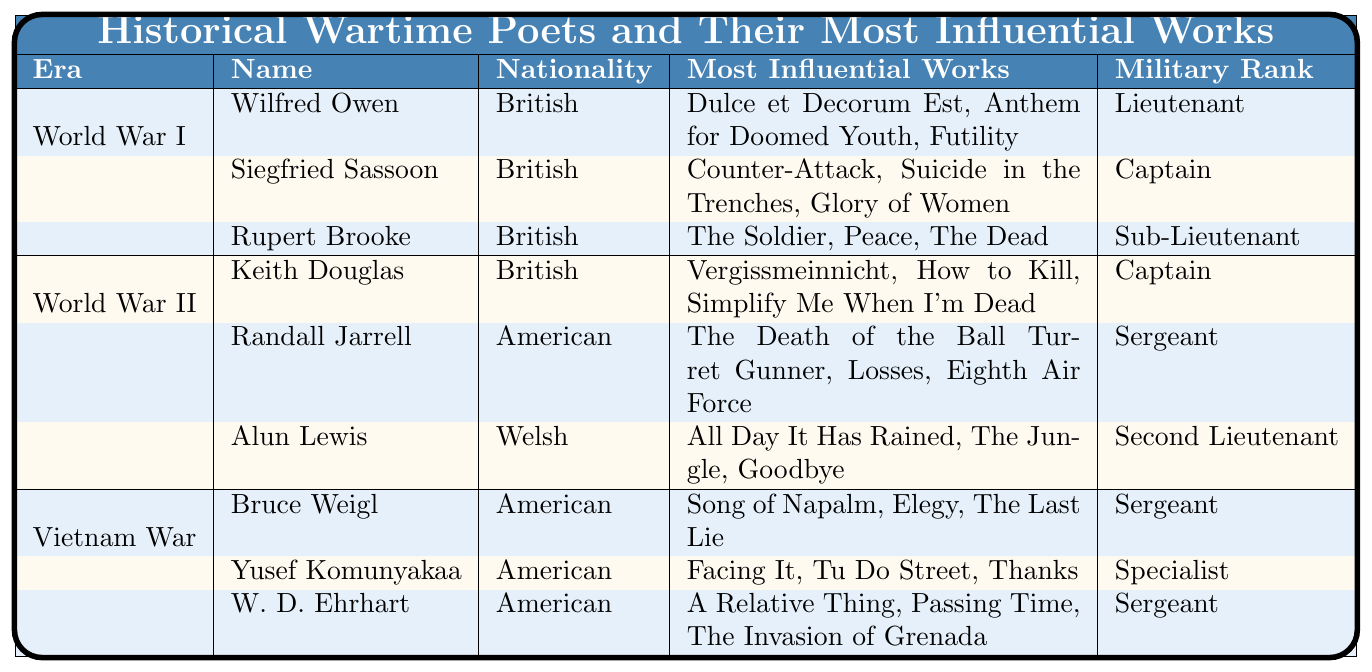What is the nationality of Wilfred Owen? The table lists Wilfred Owen under the "World War I" era and states his nationality is "British."
Answer: British Which poet has the military rank of Captain during World War II? Under the "World War II" section, Keith Douglas is the poet listed with the military rank of Captain.
Answer: Keith Douglas How many influential works does Rupert Brooke have? The table shows Rupert Brooke has three influential works listed under his name: "The Soldier," "Peace," and "The Dead."
Answer: 3 Is Yusef Komunyakaa's military rank higher than Bruce Weigl's? Yusef Komunyakaa has a military rank of Specialist, while Bruce Weigl has a rank of Sergeant. Since Specialist is a higher rank than Sergeant, the answer is yes.
Answer: Yes List the most influential works of Alun Lewis. Alun Lewis's most influential works listed in the table are "All Day It Has Rained," "The Jungle," and "Goodbye."
Answer: All Day It Has Rained, The Jungle, Goodbye Who has the fewest number of influential works, and how many are there? All poets have three influential works listed; thus, none has fewer. Hence, the answer is that all have the same number.
Answer: 3 Do any poets from the table have the same military rank? The table shows both Bruce Weigl and W. D. Ehrhart have the military rank of Sergeant, indicating that yes, there are poets with the same rank.
Answer: Yes Which poet from the Vietnam War era is listed as a Sergeant? The table lists both Bruce Weigl and W. D. Ehrhart as Sergeants under the Vietnam War section.
Answer: Bruce Weigl, W. D. Ehrhart How many poets are described in total across all eras? There are three poets from World War I, three from World War II, and three from the Vietnam War, giving a total of 9 poets.
Answer: 9 What is the most common military rank among the poets listed? By reviewing the ranks: Lieutenant (1), Captain (2), Sub-Lieutenant (1), Second Lieutenant (1), Sergeant (4), and Specialist (1), the most common rank is Sergeant with 4 individuals.
Answer: Sergeant 